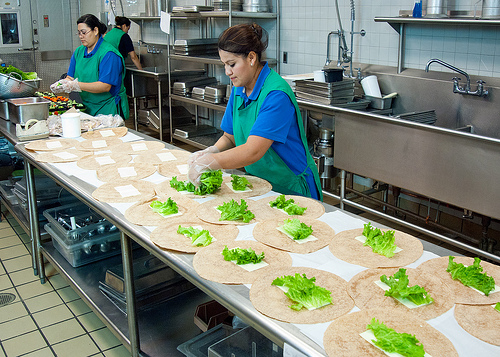Please provide the bounding box coordinate of the region this sentence describes: Rubber gloves on a woman. [0.33, 0.42, 0.49, 0.54]. The provided coordinates correctly highlight the area where the woman is wearing rubber gloves, located midway on her forearm and encompassing her hands. 